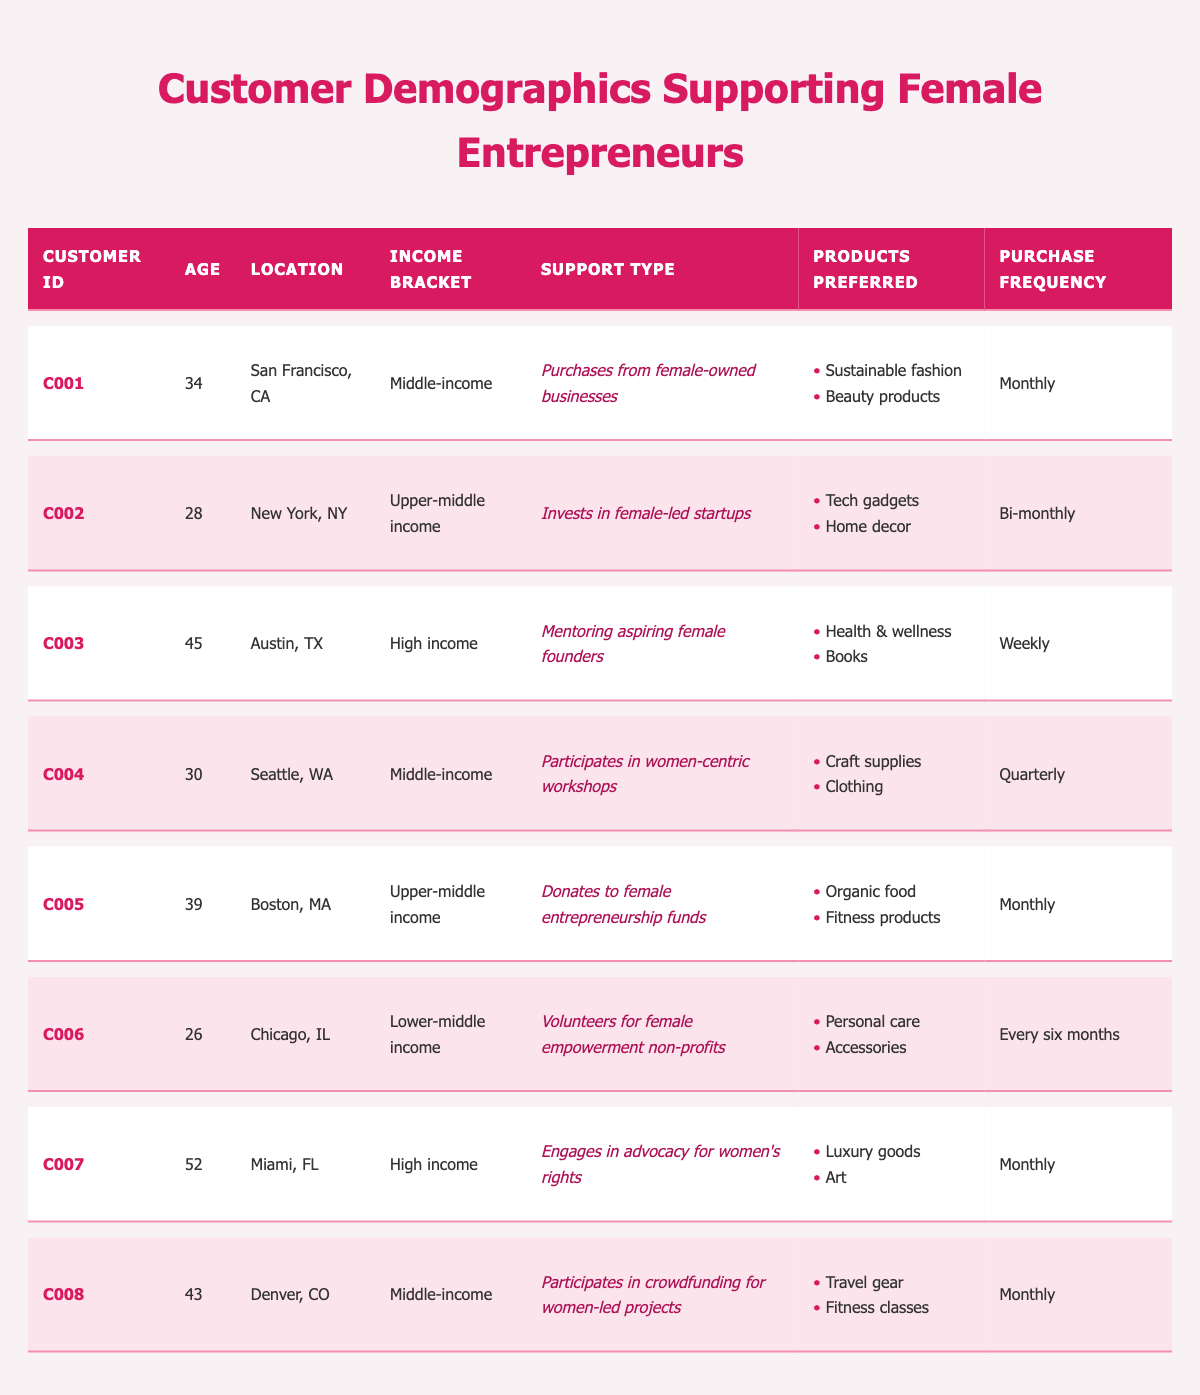What is the age of the customer from Miami, FL? The customer from Miami, FL is identified as "C007" in the table. The age listed for this customer is 52.
Answer: 52 Which customer has the highest income bracket? The customer "C003" from Austin, TX has a "High income" bracket, which is the highest income category present in the data.
Answer: C003 How many customers support female-led startups? There is 1 customer, identified as "C002", who supports female-led startups by investing in them.
Answer: 1 What types of products are preferred by the customer who donates to female entrepreneurship funds? The customer "C005" who donates to female entrepreneurship funds prefers "Organic food" and "Fitness products" according to the table.
Answer: Organic food, Fitness products What is the average age of all customers listed? The ages of the customers are: 34, 28, 45, 30, 39, 26, 52, 43. Summing these gives: 34 + 28 + 45 + 30 + 39 + 26 + 52 + 43 = 297. There are 8 customers, so the average age is 297 / 8 = 37.125, which rounds to 37.
Answer: 37 True or False: All customers purchase products monthly. The purchase frequency data indicates that not all customers purchase products monthly; for example, customer "C004" purchases quarterly and "C006" purchases every six months.
Answer: False How many customers prefer health-related products? The customers "C003" and "C005" (preferred products: Health & wellness, Organic food) are the only ones who focus on health-related products, meaning there are 2 customers in total.
Answer: 2 Is there a customer from Chicago who supports female empowerment? Yes, customer "C006" from Chicago volunteers for female empowerment non-profits, indicating their support for female empowerment.
Answer: Yes What is the most common purchase frequency among the customers? Upon reviewing the table, the majority of customers (5 out of 8) have a "Monthly" purchase frequency, making it the most common one among them.
Answer: Monthly 